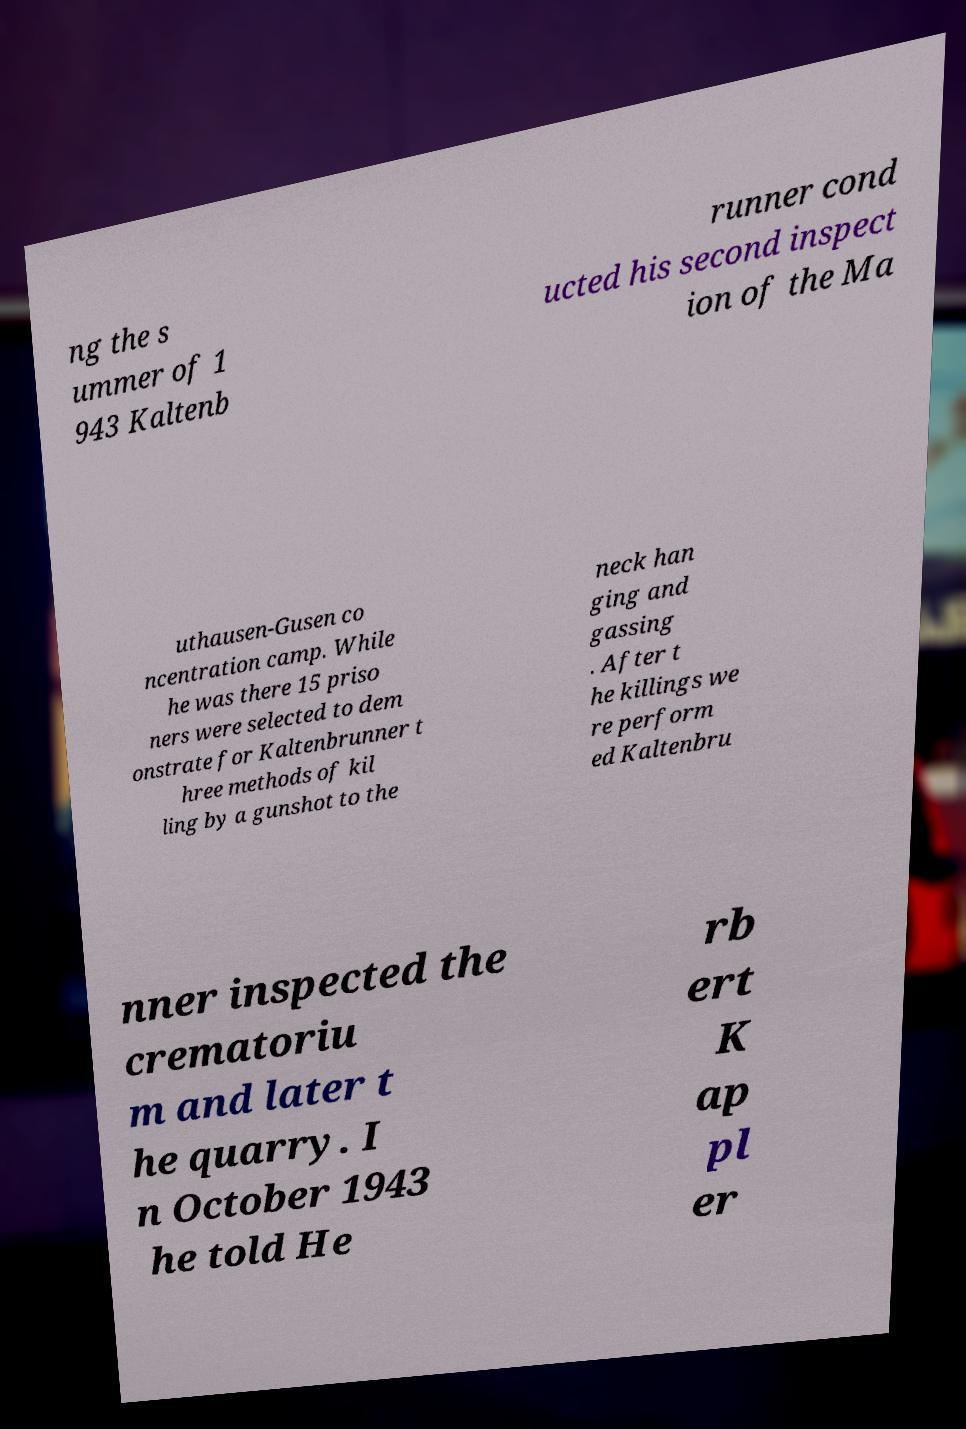Could you assist in decoding the text presented in this image and type it out clearly? ng the s ummer of 1 943 Kaltenb runner cond ucted his second inspect ion of the Ma uthausen-Gusen co ncentration camp. While he was there 15 priso ners were selected to dem onstrate for Kaltenbrunner t hree methods of kil ling by a gunshot to the neck han ging and gassing . After t he killings we re perform ed Kaltenbru nner inspected the crematoriu m and later t he quarry. I n October 1943 he told He rb ert K ap pl er 